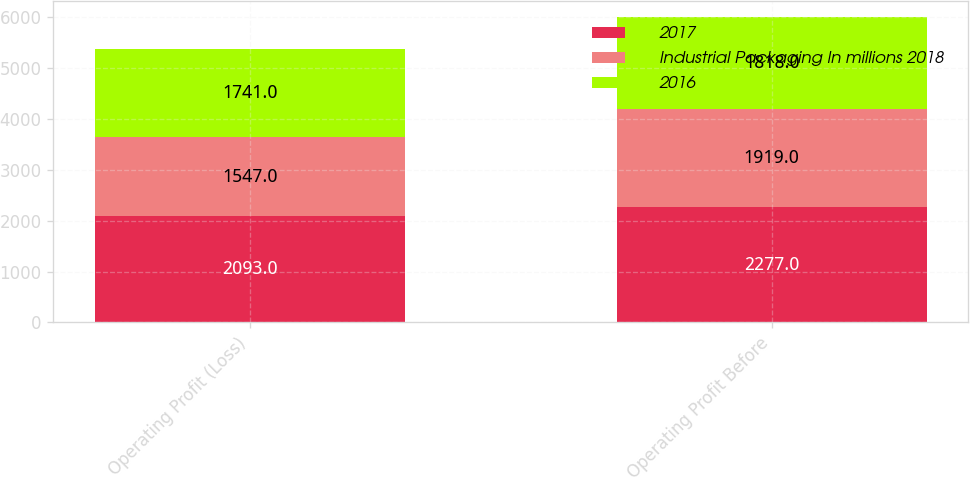Convert chart to OTSL. <chart><loc_0><loc_0><loc_500><loc_500><stacked_bar_chart><ecel><fcel>Operating Profit (Loss)<fcel>Operating Profit Before<nl><fcel>2017<fcel>2093<fcel>2277<nl><fcel>Industrial Packaging In millions 2018<fcel>1547<fcel>1919<nl><fcel>2016<fcel>1741<fcel>1818<nl></chart> 